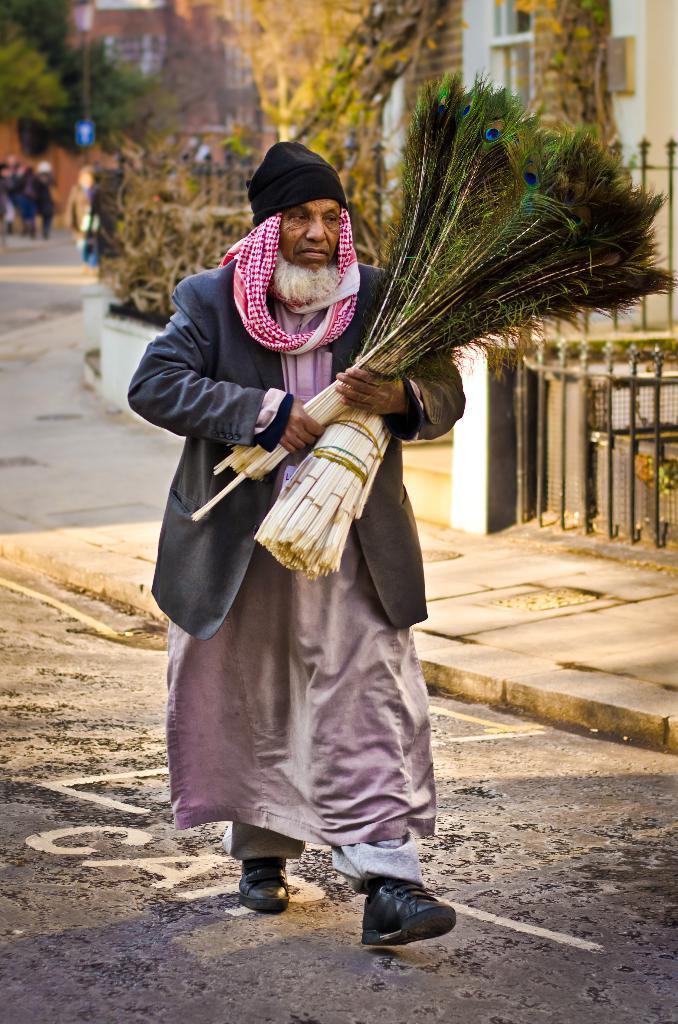Can you describe this image briefly? In the center of the image we can see one person is walking on the road. And he is in a different costume and he is holding peacock feathers. In the background, we can see buildings, trees, fences, one sign board, few people are standing and a few other objects. 